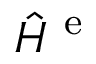Convert formula to latex. <formula><loc_0><loc_0><loc_500><loc_500>\hat { H } ^ { e }</formula> 